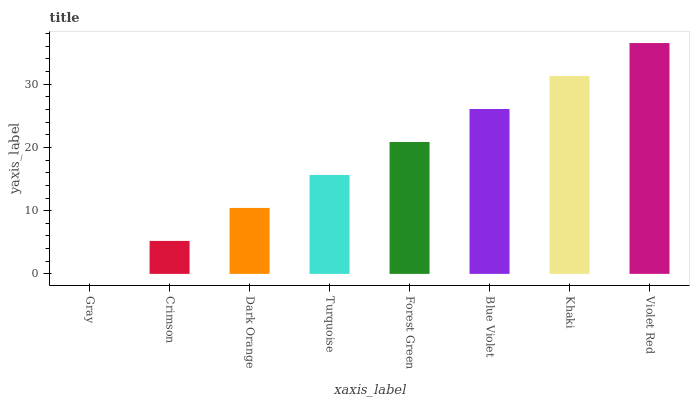Is Crimson the minimum?
Answer yes or no. No. Is Crimson the maximum?
Answer yes or no. No. Is Crimson greater than Gray?
Answer yes or no. Yes. Is Gray less than Crimson?
Answer yes or no. Yes. Is Gray greater than Crimson?
Answer yes or no. No. Is Crimson less than Gray?
Answer yes or no. No. Is Forest Green the high median?
Answer yes or no. Yes. Is Turquoise the low median?
Answer yes or no. Yes. Is Crimson the high median?
Answer yes or no. No. Is Dark Orange the low median?
Answer yes or no. No. 